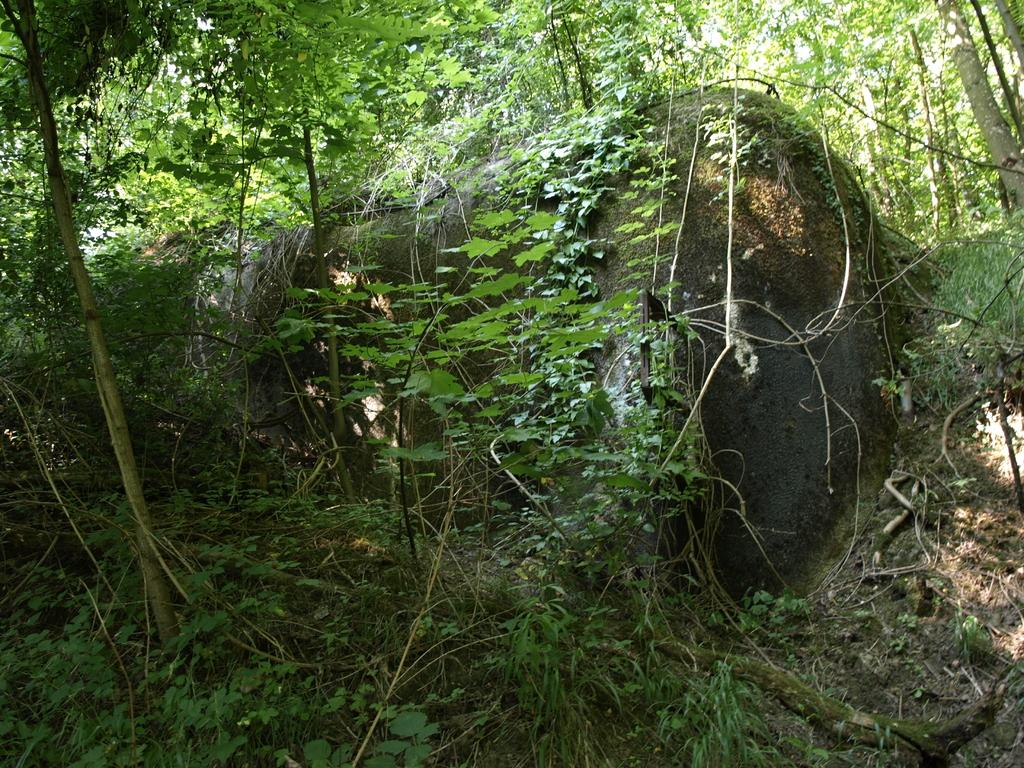What is growing on the rock in the image? There are creepers on the rock in the image. What type of vegetation can be seen in the background of the image? There are plants and trees in the background of the image. What type of terrain is visible in the background of the image? The land is visible in the background of the image. What type of humor can be seen in the image? There is no humor present in the image; it features creepers on a rock and vegetation in the background. 